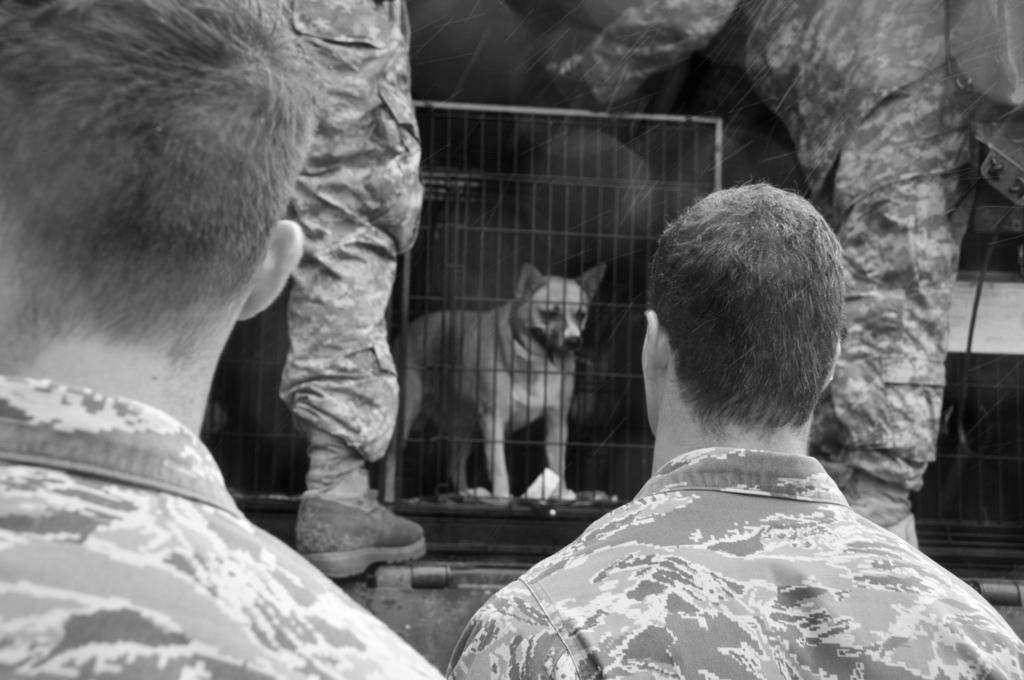Can you describe this image briefly? On the left side, there is a person in an uniform. Beside him, there is another person. In the background, there are two persons standing, in between them, there is a dog in a cage. 